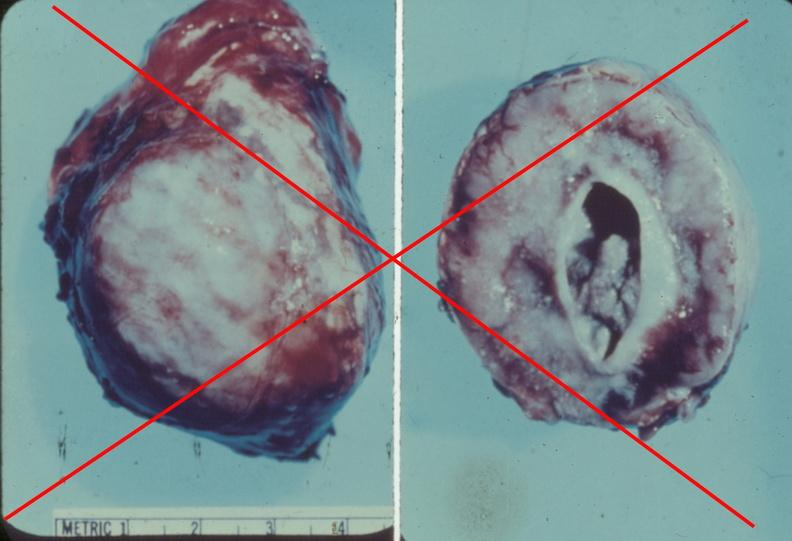what is present?
Answer the question using a single word or phrase. Endocrine 